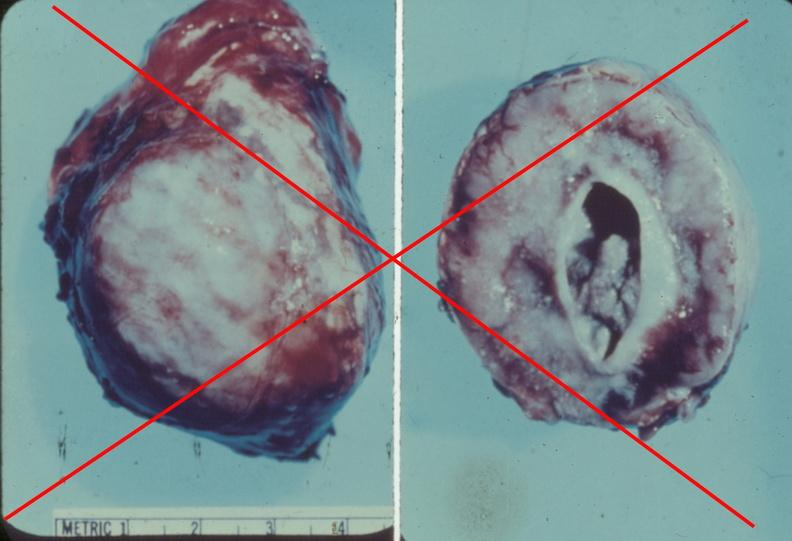what is present?
Answer the question using a single word or phrase. Endocrine 